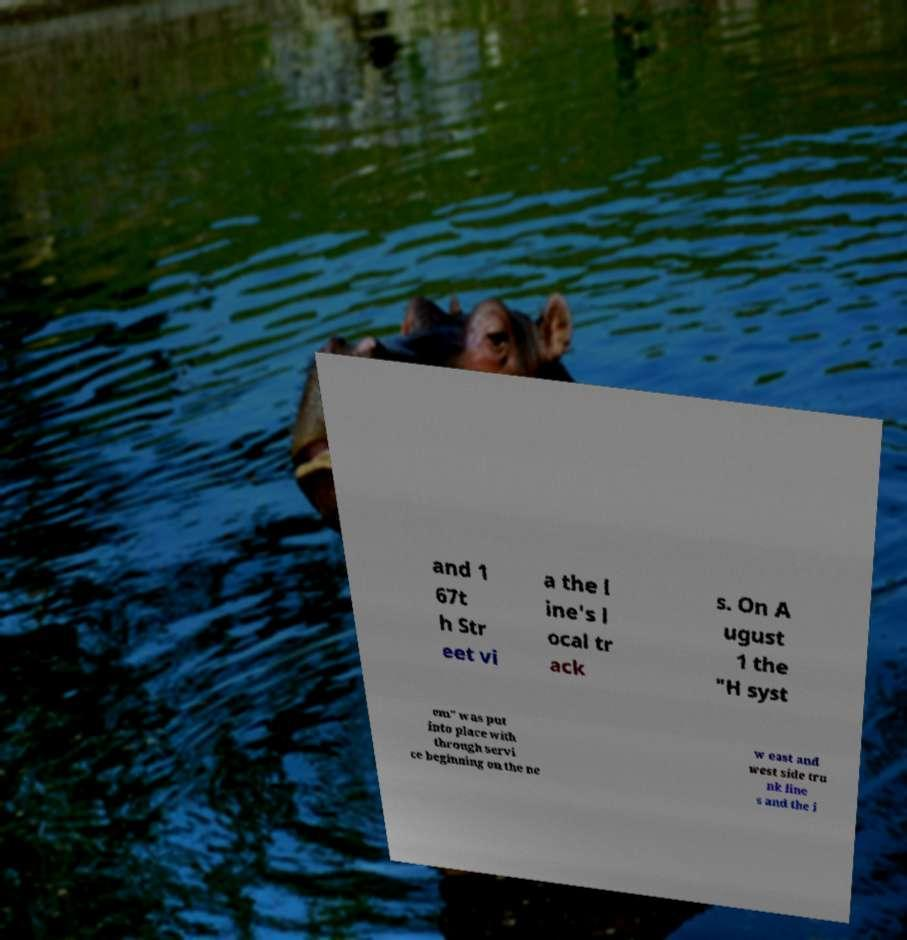Can you accurately transcribe the text from the provided image for me? and 1 67t h Str eet vi a the l ine's l ocal tr ack s. On A ugust 1 the "H syst em" was put into place with through servi ce beginning on the ne w east and west side tru nk line s and the i 